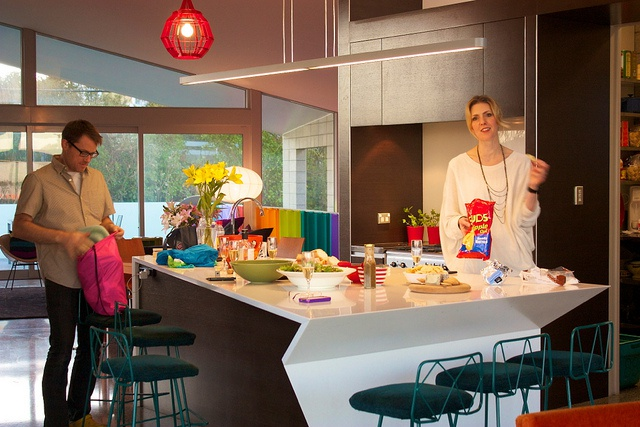Describe the objects in this image and their specific colors. I can see dining table in brown, black, darkgray, lightgray, and tan tones, people in brown, black, maroon, and gray tones, people in brown, tan, and red tones, chair in brown, black, darkgray, and teal tones, and chair in brown, black, teal, and darkgray tones in this image. 